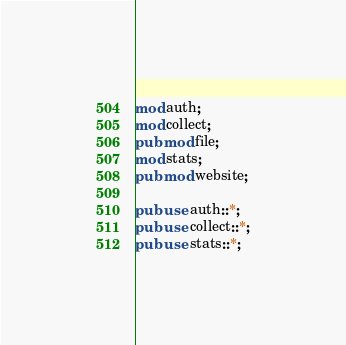Convert code to text. <code><loc_0><loc_0><loc_500><loc_500><_Rust_>mod auth;
mod collect;
pub mod file;
mod stats;
pub mod website;

pub use auth::*;
pub use collect::*;
pub use stats::*;
</code> 